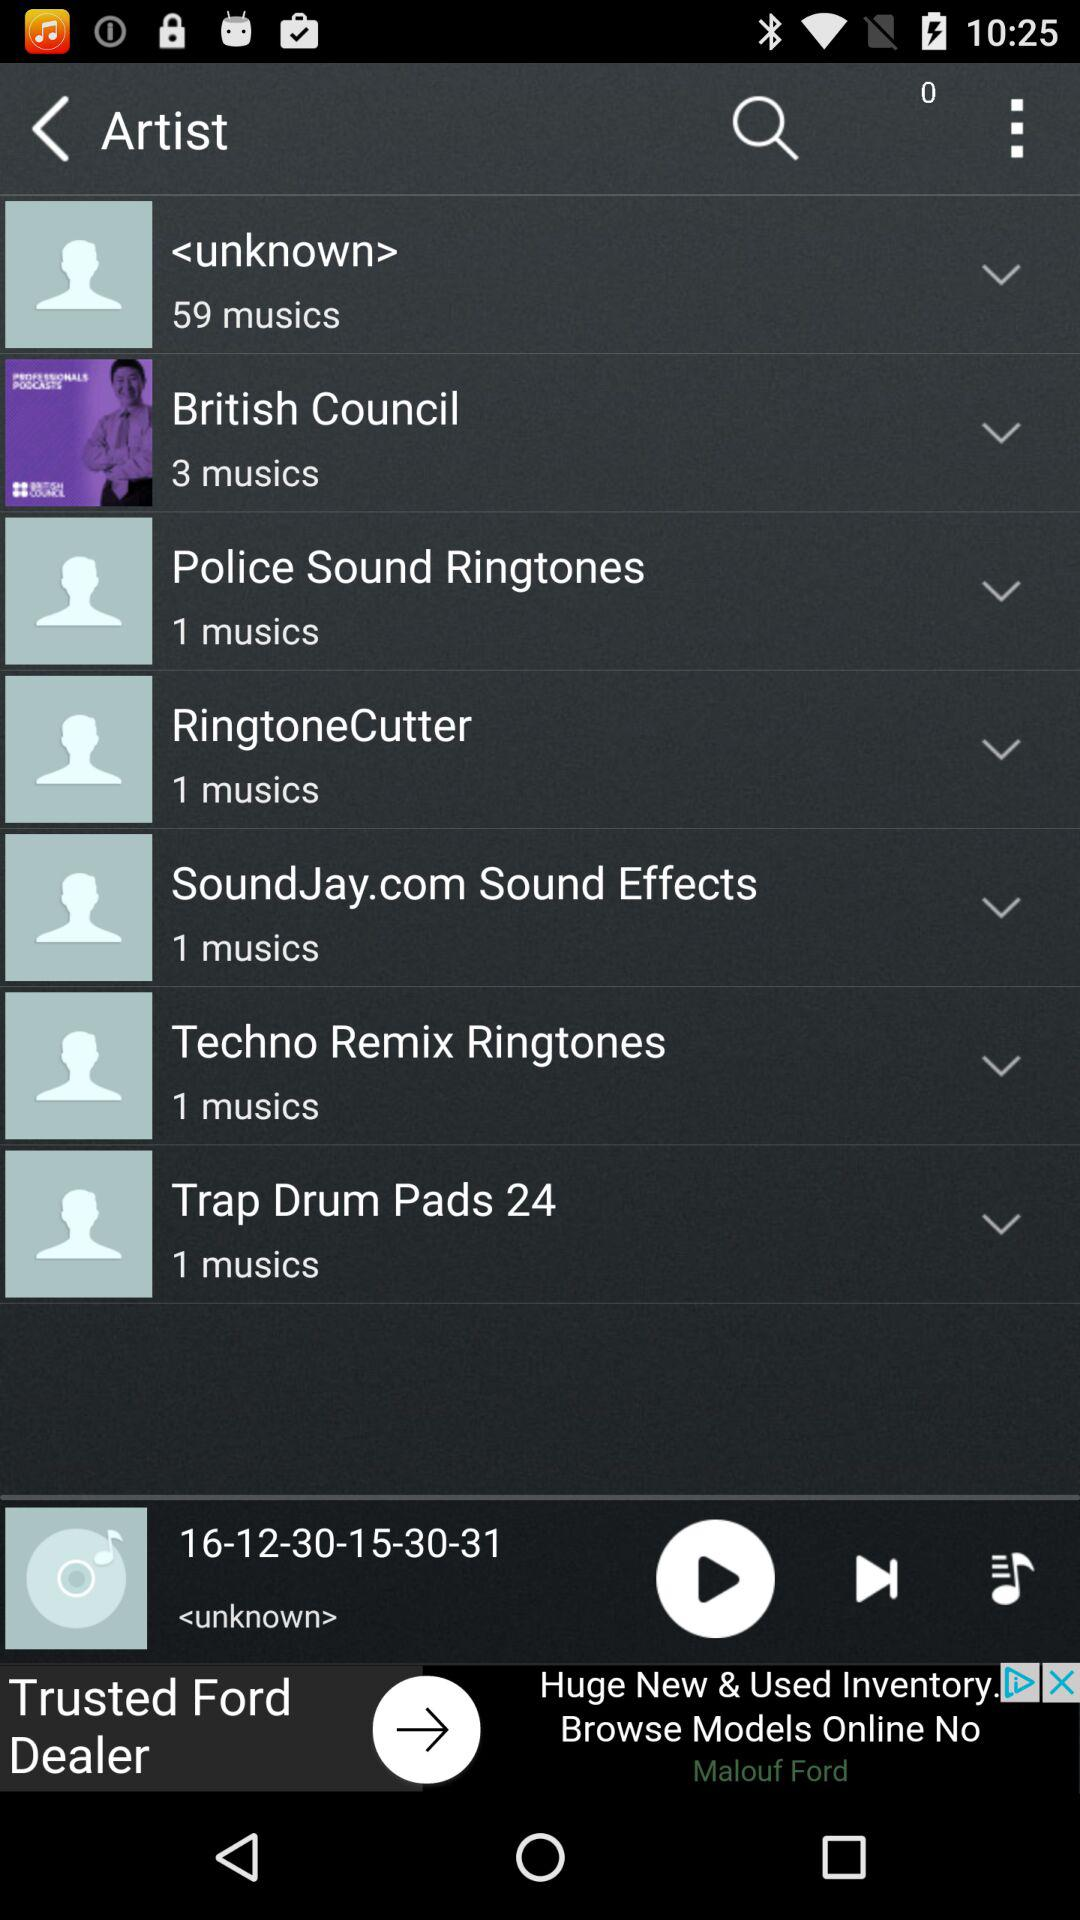How many music are available by unknown artists? There are 59 music available by unknown artists. 